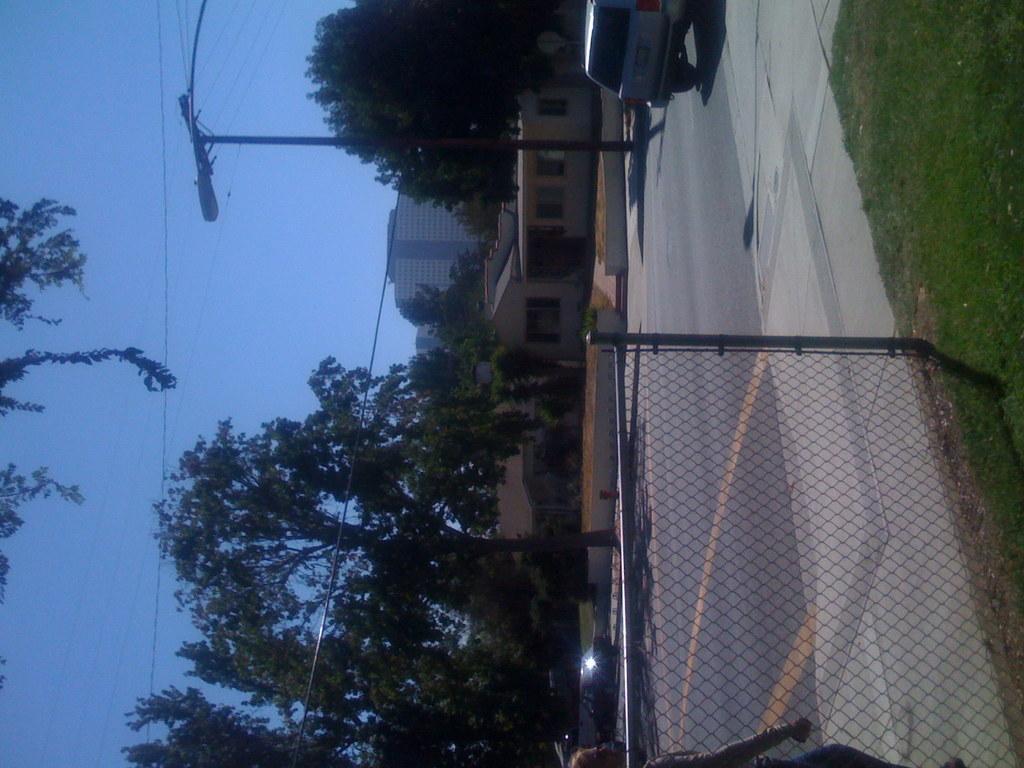Describe this image in one or two sentences. In front of the image there is a person walking on the pavement, beside the pavement there is a mesh fence with metal rods, there is grass on the surface, there are cars passing on the road. In the background of the image there are lamp posts, trees, buildings and electrical cables on top the poles. 